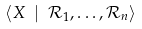<formula> <loc_0><loc_0><loc_500><loc_500>\langle X \ | \ \mathcal { R } _ { 1 } , \dots , \mathcal { R } _ { n } \rangle</formula> 